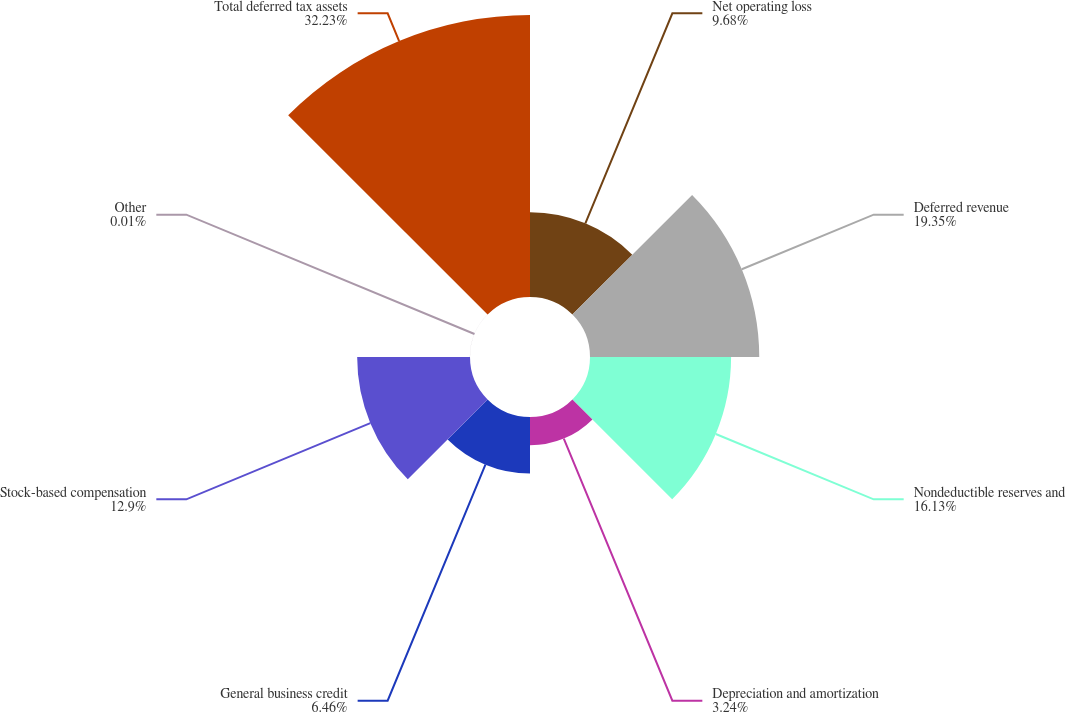Convert chart. <chart><loc_0><loc_0><loc_500><loc_500><pie_chart><fcel>Net operating loss<fcel>Deferred revenue<fcel>Nondeductible reserves and<fcel>Depreciation and amortization<fcel>General business credit<fcel>Stock-based compensation<fcel>Other<fcel>Total deferred tax assets<nl><fcel>9.68%<fcel>19.35%<fcel>16.13%<fcel>3.24%<fcel>6.46%<fcel>12.9%<fcel>0.01%<fcel>32.24%<nl></chart> 